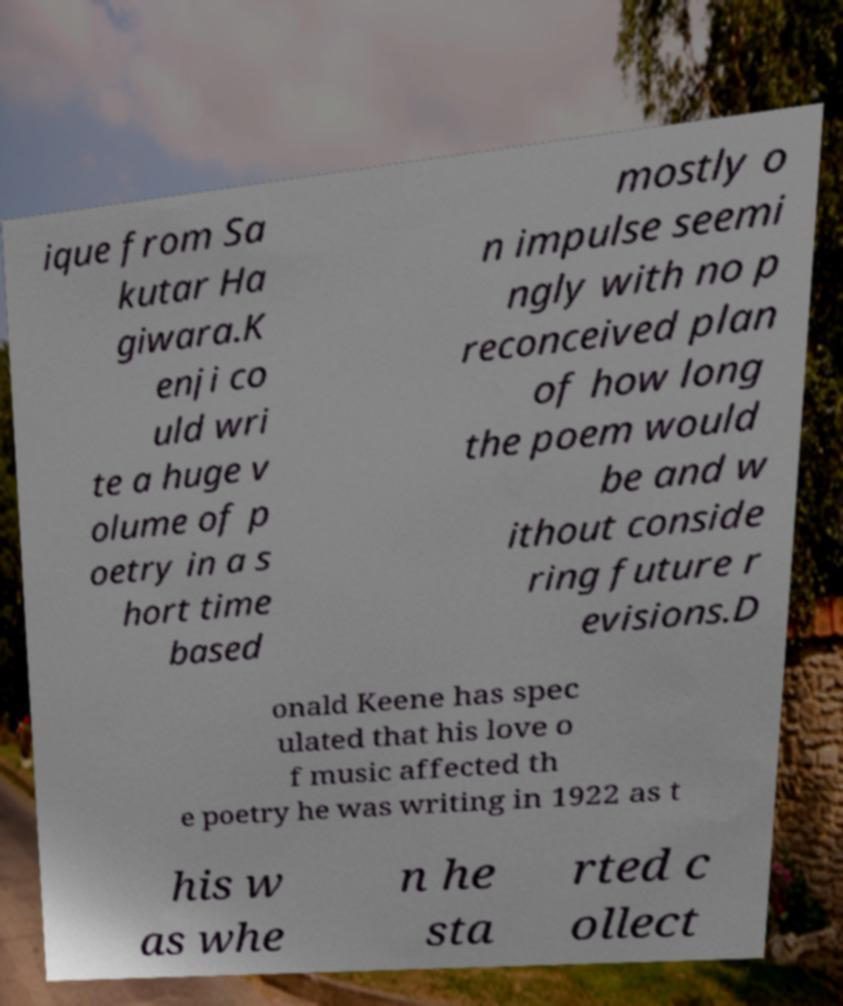Please read and relay the text visible in this image. What does it say? ique from Sa kutar Ha giwara.K enji co uld wri te a huge v olume of p oetry in a s hort time based mostly o n impulse seemi ngly with no p reconceived plan of how long the poem would be and w ithout conside ring future r evisions.D onald Keene has spec ulated that his love o f music affected th e poetry he was writing in 1922 as t his w as whe n he sta rted c ollect 